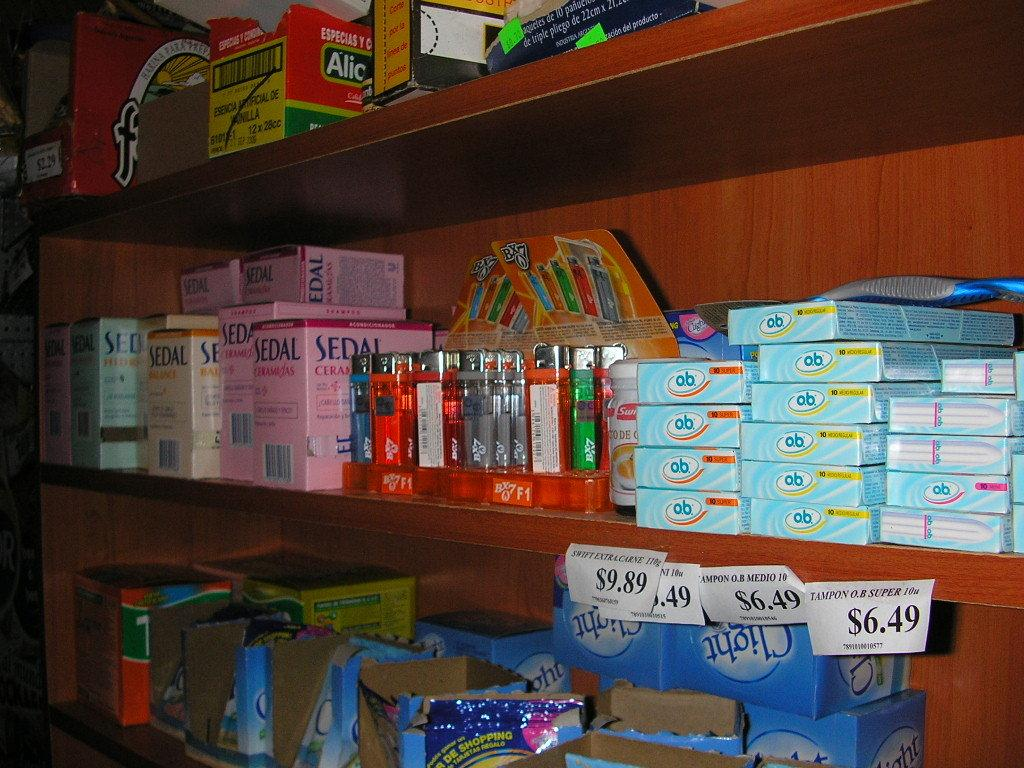Provide a one-sentence caption for the provided image. Store shelf that shows objects on sale including a pink box of SEDAL. 